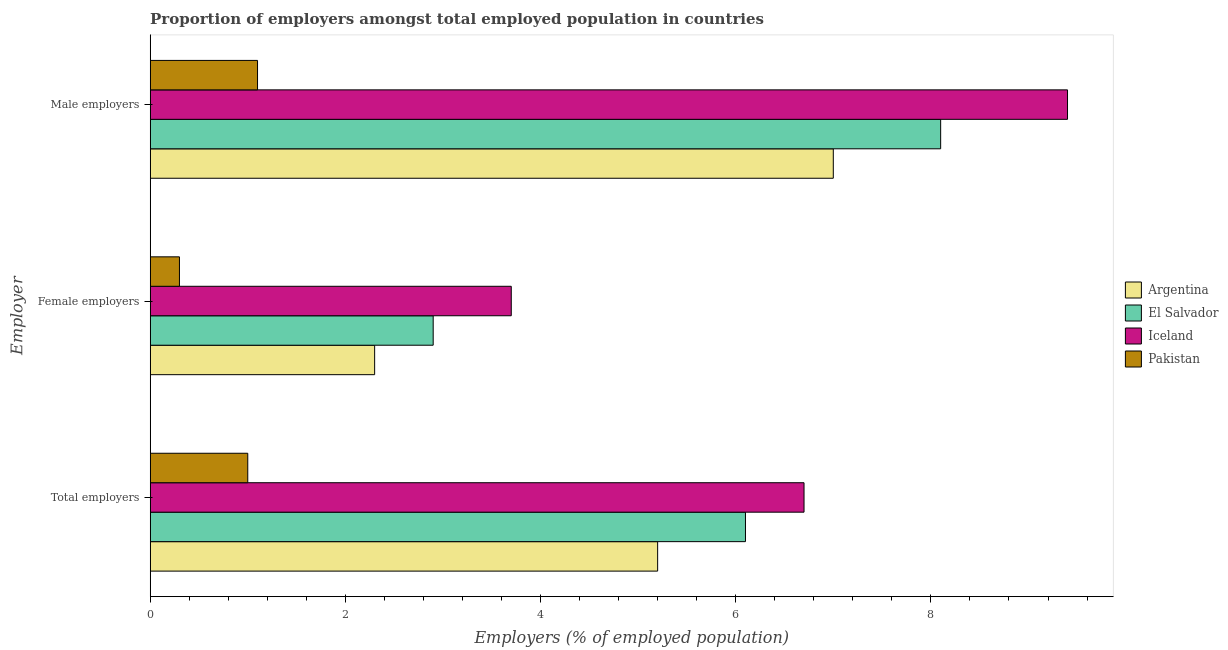How many bars are there on the 2nd tick from the top?
Ensure brevity in your answer.  4. How many bars are there on the 2nd tick from the bottom?
Your answer should be very brief. 4. What is the label of the 3rd group of bars from the top?
Make the answer very short. Total employers. What is the percentage of total employers in Iceland?
Offer a terse response. 6.7. Across all countries, what is the maximum percentage of total employers?
Provide a succinct answer. 6.7. Across all countries, what is the minimum percentage of male employers?
Provide a short and direct response. 1.1. In which country was the percentage of total employers maximum?
Ensure brevity in your answer.  Iceland. In which country was the percentage of male employers minimum?
Ensure brevity in your answer.  Pakistan. What is the total percentage of male employers in the graph?
Offer a terse response. 25.6. What is the difference between the percentage of total employers in Iceland and that in Pakistan?
Give a very brief answer. 5.7. What is the difference between the percentage of total employers in Argentina and the percentage of female employers in Pakistan?
Give a very brief answer. 4.9. What is the average percentage of male employers per country?
Your answer should be compact. 6.4. What is the difference between the percentage of female employers and percentage of male employers in Argentina?
Give a very brief answer. -4.7. In how many countries, is the percentage of total employers greater than 3.6 %?
Your response must be concise. 3. What is the ratio of the percentage of male employers in Pakistan to that in Argentina?
Provide a short and direct response. 0.16. What is the difference between the highest and the second highest percentage of total employers?
Provide a short and direct response. 0.6. What is the difference between the highest and the lowest percentage of female employers?
Your response must be concise. 3.4. In how many countries, is the percentage of female employers greater than the average percentage of female employers taken over all countries?
Provide a short and direct response. 2. How many bars are there?
Provide a short and direct response. 12. Are the values on the major ticks of X-axis written in scientific E-notation?
Keep it short and to the point. No. Does the graph contain any zero values?
Keep it short and to the point. No. How many legend labels are there?
Ensure brevity in your answer.  4. What is the title of the graph?
Your answer should be very brief. Proportion of employers amongst total employed population in countries. Does "Panama" appear as one of the legend labels in the graph?
Your answer should be compact. No. What is the label or title of the X-axis?
Ensure brevity in your answer.  Employers (% of employed population). What is the label or title of the Y-axis?
Provide a succinct answer. Employer. What is the Employers (% of employed population) in Argentina in Total employers?
Give a very brief answer. 5.2. What is the Employers (% of employed population) in El Salvador in Total employers?
Keep it short and to the point. 6.1. What is the Employers (% of employed population) of Iceland in Total employers?
Your response must be concise. 6.7. What is the Employers (% of employed population) of Argentina in Female employers?
Your answer should be compact. 2.3. What is the Employers (% of employed population) in El Salvador in Female employers?
Provide a succinct answer. 2.9. What is the Employers (% of employed population) of Iceland in Female employers?
Offer a terse response. 3.7. What is the Employers (% of employed population) of Pakistan in Female employers?
Make the answer very short. 0.3. What is the Employers (% of employed population) in Argentina in Male employers?
Keep it short and to the point. 7. What is the Employers (% of employed population) of El Salvador in Male employers?
Offer a terse response. 8.1. What is the Employers (% of employed population) in Iceland in Male employers?
Make the answer very short. 9.4. What is the Employers (% of employed population) of Pakistan in Male employers?
Give a very brief answer. 1.1. Across all Employer, what is the maximum Employers (% of employed population) of El Salvador?
Ensure brevity in your answer.  8.1. Across all Employer, what is the maximum Employers (% of employed population) in Iceland?
Ensure brevity in your answer.  9.4. Across all Employer, what is the maximum Employers (% of employed population) in Pakistan?
Make the answer very short. 1.1. Across all Employer, what is the minimum Employers (% of employed population) in Argentina?
Your answer should be very brief. 2.3. Across all Employer, what is the minimum Employers (% of employed population) in El Salvador?
Make the answer very short. 2.9. Across all Employer, what is the minimum Employers (% of employed population) in Iceland?
Make the answer very short. 3.7. Across all Employer, what is the minimum Employers (% of employed population) in Pakistan?
Your response must be concise. 0.3. What is the total Employers (% of employed population) in Argentina in the graph?
Offer a very short reply. 14.5. What is the total Employers (% of employed population) in El Salvador in the graph?
Provide a short and direct response. 17.1. What is the total Employers (% of employed population) of Iceland in the graph?
Provide a succinct answer. 19.8. What is the total Employers (% of employed population) of Pakistan in the graph?
Your answer should be compact. 2.4. What is the difference between the Employers (% of employed population) of Argentina in Total employers and that in Female employers?
Offer a terse response. 2.9. What is the difference between the Employers (% of employed population) in Iceland in Total employers and that in Female employers?
Ensure brevity in your answer.  3. What is the difference between the Employers (% of employed population) in Pakistan in Total employers and that in Female employers?
Your response must be concise. 0.7. What is the difference between the Employers (% of employed population) in Argentina in Total employers and that in Male employers?
Provide a succinct answer. -1.8. What is the difference between the Employers (% of employed population) in El Salvador in Total employers and that in Male employers?
Your response must be concise. -2. What is the difference between the Employers (% of employed population) of Iceland in Total employers and that in Male employers?
Provide a short and direct response. -2.7. What is the difference between the Employers (% of employed population) of Argentina in Female employers and that in Male employers?
Your response must be concise. -4.7. What is the difference between the Employers (% of employed population) in El Salvador in Female employers and that in Male employers?
Provide a succinct answer. -5.2. What is the difference between the Employers (% of employed population) in Argentina in Total employers and the Employers (% of employed population) in Pakistan in Female employers?
Your response must be concise. 4.9. What is the difference between the Employers (% of employed population) of Iceland in Total employers and the Employers (% of employed population) of Pakistan in Female employers?
Offer a terse response. 6.4. What is the difference between the Employers (% of employed population) of Argentina in Total employers and the Employers (% of employed population) of Pakistan in Male employers?
Your answer should be very brief. 4.1. What is the difference between the Employers (% of employed population) of Argentina in Female employers and the Employers (% of employed population) of El Salvador in Male employers?
Your response must be concise. -5.8. What is the difference between the Employers (% of employed population) in Argentina in Female employers and the Employers (% of employed population) in Iceland in Male employers?
Keep it short and to the point. -7.1. What is the difference between the Employers (% of employed population) in Argentina in Female employers and the Employers (% of employed population) in Pakistan in Male employers?
Give a very brief answer. 1.2. What is the average Employers (% of employed population) in Argentina per Employer?
Keep it short and to the point. 4.83. What is the average Employers (% of employed population) in El Salvador per Employer?
Make the answer very short. 5.7. What is the average Employers (% of employed population) in Iceland per Employer?
Make the answer very short. 6.6. What is the average Employers (% of employed population) of Pakistan per Employer?
Offer a very short reply. 0.8. What is the difference between the Employers (% of employed population) in Argentina and Employers (% of employed population) in Iceland in Total employers?
Offer a very short reply. -1.5. What is the difference between the Employers (% of employed population) of El Salvador and Employers (% of employed population) of Pakistan in Total employers?
Provide a short and direct response. 5.1. What is the difference between the Employers (% of employed population) in Argentina and Employers (% of employed population) in Pakistan in Female employers?
Give a very brief answer. 2. What is the difference between the Employers (% of employed population) of Iceland and Employers (% of employed population) of Pakistan in Female employers?
Your answer should be compact. 3.4. What is the difference between the Employers (% of employed population) of Argentina and Employers (% of employed population) of Iceland in Male employers?
Ensure brevity in your answer.  -2.4. What is the difference between the Employers (% of employed population) of Argentina and Employers (% of employed population) of Pakistan in Male employers?
Provide a succinct answer. 5.9. What is the ratio of the Employers (% of employed population) in Argentina in Total employers to that in Female employers?
Ensure brevity in your answer.  2.26. What is the ratio of the Employers (% of employed population) of El Salvador in Total employers to that in Female employers?
Ensure brevity in your answer.  2.1. What is the ratio of the Employers (% of employed population) of Iceland in Total employers to that in Female employers?
Give a very brief answer. 1.81. What is the ratio of the Employers (% of employed population) of Pakistan in Total employers to that in Female employers?
Your answer should be compact. 3.33. What is the ratio of the Employers (% of employed population) in Argentina in Total employers to that in Male employers?
Provide a short and direct response. 0.74. What is the ratio of the Employers (% of employed population) of El Salvador in Total employers to that in Male employers?
Your response must be concise. 0.75. What is the ratio of the Employers (% of employed population) in Iceland in Total employers to that in Male employers?
Your answer should be very brief. 0.71. What is the ratio of the Employers (% of employed population) of Argentina in Female employers to that in Male employers?
Your response must be concise. 0.33. What is the ratio of the Employers (% of employed population) of El Salvador in Female employers to that in Male employers?
Offer a terse response. 0.36. What is the ratio of the Employers (% of employed population) in Iceland in Female employers to that in Male employers?
Provide a succinct answer. 0.39. What is the ratio of the Employers (% of employed population) of Pakistan in Female employers to that in Male employers?
Your answer should be very brief. 0.27. What is the difference between the highest and the second highest Employers (% of employed population) of Iceland?
Ensure brevity in your answer.  2.7. What is the difference between the highest and the second highest Employers (% of employed population) of Pakistan?
Offer a very short reply. 0.1. What is the difference between the highest and the lowest Employers (% of employed population) of Argentina?
Offer a terse response. 4.7. What is the difference between the highest and the lowest Employers (% of employed population) of El Salvador?
Your answer should be very brief. 5.2. What is the difference between the highest and the lowest Employers (% of employed population) in Pakistan?
Make the answer very short. 0.8. 